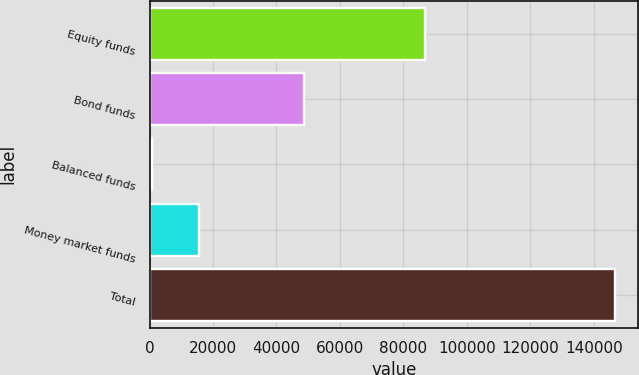Convert chart to OTSL. <chart><loc_0><loc_0><loc_500><loc_500><bar_chart><fcel>Equity funds<fcel>Bond funds<fcel>Balanced funds<fcel>Money market funds<fcel>Total<nl><fcel>86751<fcel>48789<fcel>914<fcel>15480.4<fcel>146578<nl></chart> 